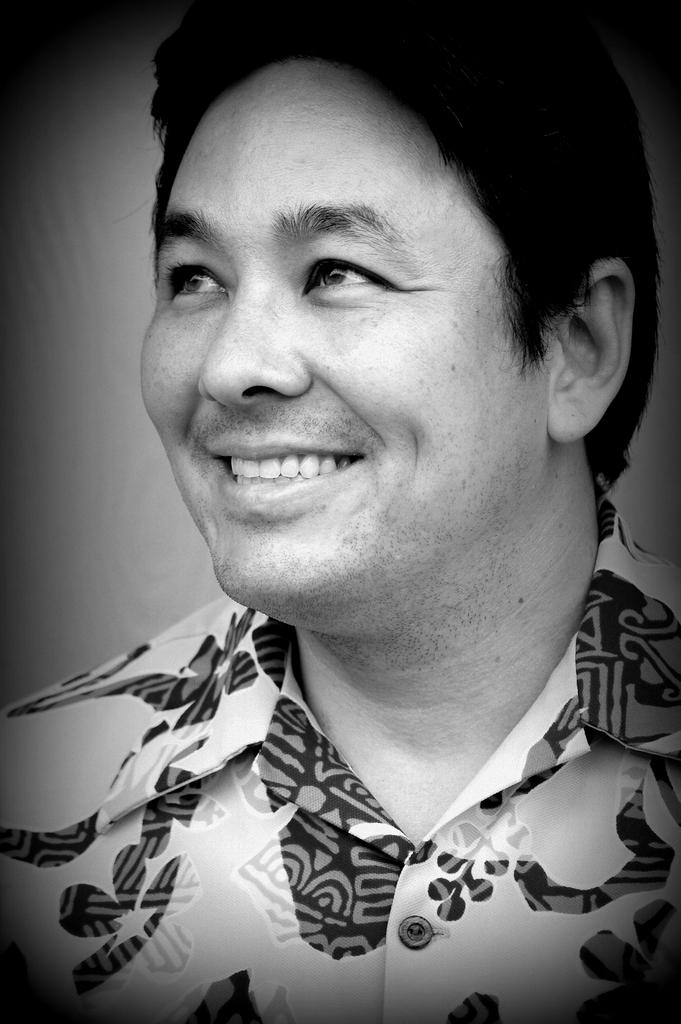What is present in the image? There is a man in the image. How is the man's facial expression in the image? The man is smiling in the image. What type of jeans is the tree wearing in the image? There is no tree or jeans present in the image; it only features a man who is smiling. 